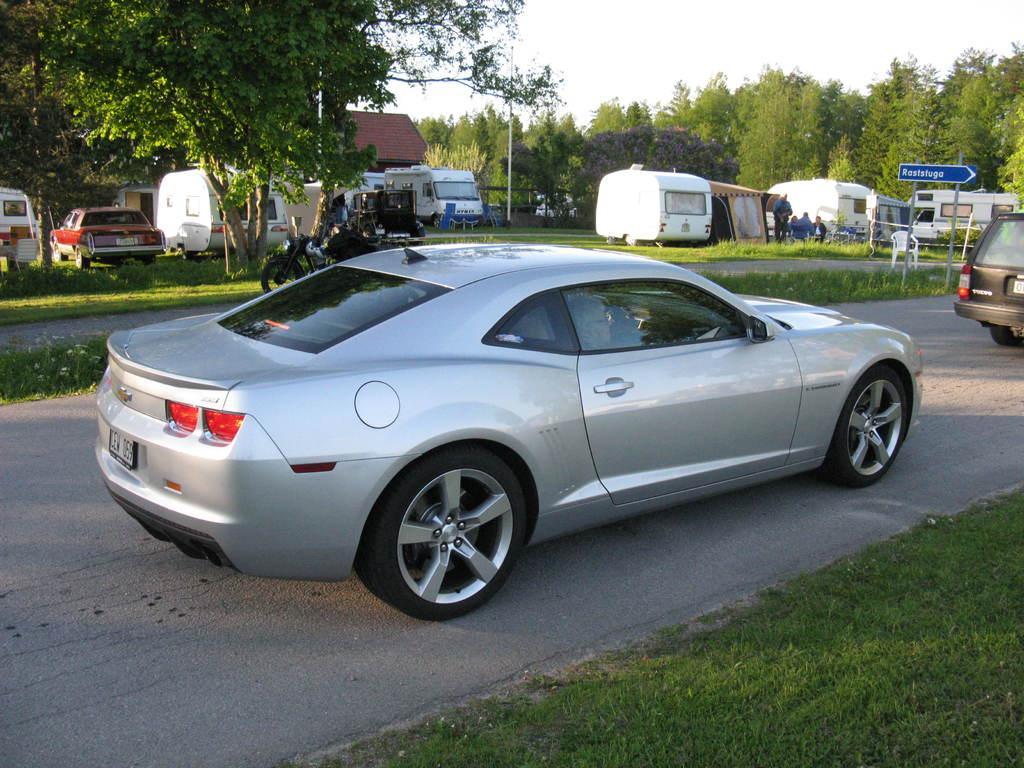In one or two sentences, can you explain what this image depicts? There are roads. On the road there are vehicles. On the ground there is grass. In the back there are many vehicles, trees and a building. Also there is a sign board with poles. Near to that there is a chair. In the background there is sky. 